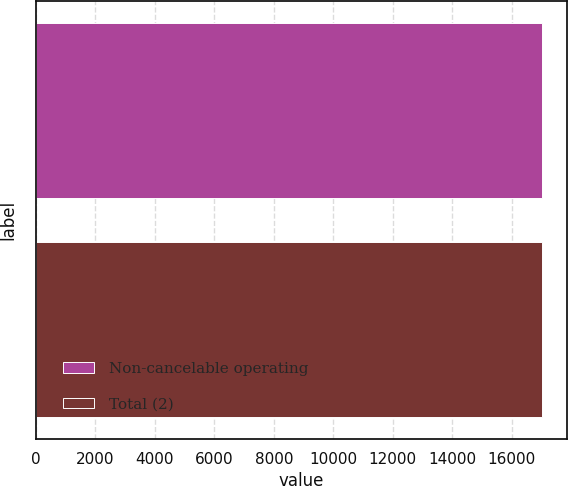Convert chart. <chart><loc_0><loc_0><loc_500><loc_500><bar_chart><fcel>Non-cancelable operating<fcel>Total (2)<nl><fcel>17009<fcel>17011<nl></chart> 